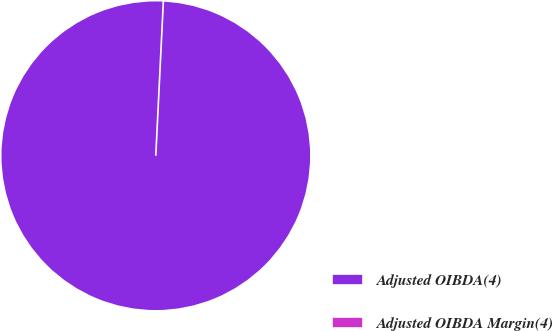<chart> <loc_0><loc_0><loc_500><loc_500><pie_chart><fcel>Adjusted OIBDA(4)<fcel>Adjusted OIBDA Margin(4)<nl><fcel>100.0%<fcel>0.0%<nl></chart> 